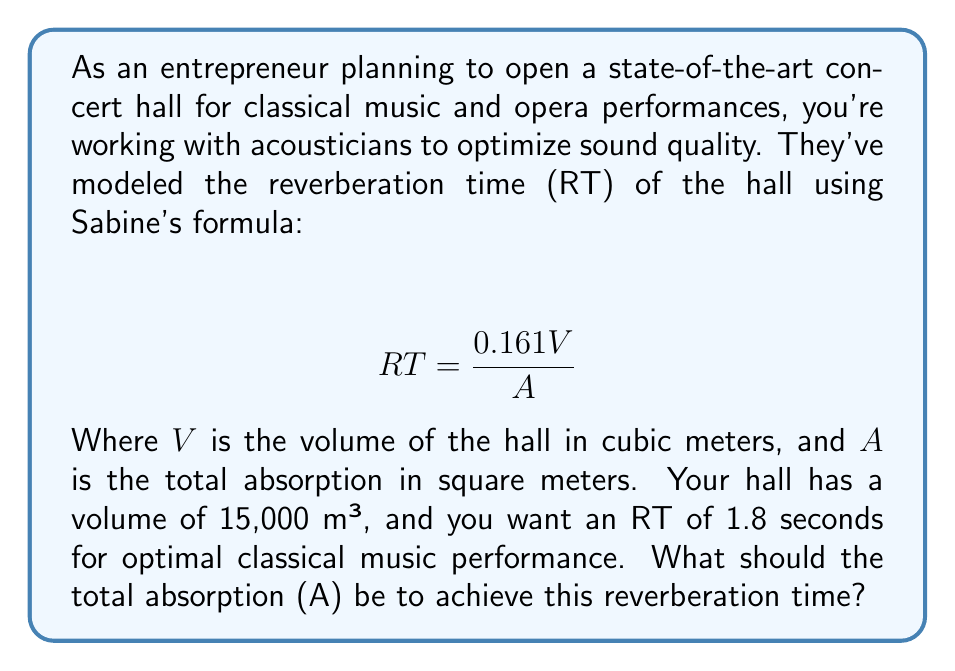Help me with this question. To solve this problem, we'll use Sabine's formula and follow these steps:

1) We start with the given formula:
   $$ RT = \frac{0.161V}{A} $$

2) We know the following values:
   - RT (Reverberation Time) = 1.8 seconds
   - V (Volume) = 15,000 m³

3) We need to solve for A (Total Absorption). Let's rearrange the formula:
   $$ A = \frac{0.161V}{RT} $$

4) Now, let's substitute the known values:
   $$ A = \frac{0.161 \times 15,000}{1.8} $$

5) Let's calculate:
   $$ A = \frac{2,415}{1.8} = 1,341.67 $$

6) Round to two decimal places:
   $$ A \approx 1,341.67 \text{ m²} $$

Therefore, the total absorption should be approximately 1,341.67 square meters to achieve the desired reverberation time of 1.8 seconds in your concert hall.
Answer: 1,341.67 m² 